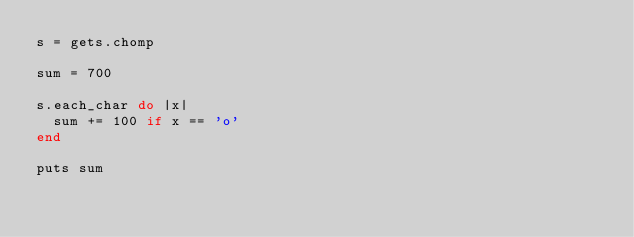Convert code to text. <code><loc_0><loc_0><loc_500><loc_500><_Ruby_>s = gets.chomp

sum = 700

s.each_char do |x|
  sum += 100 if x == 'o'
end

puts sum</code> 